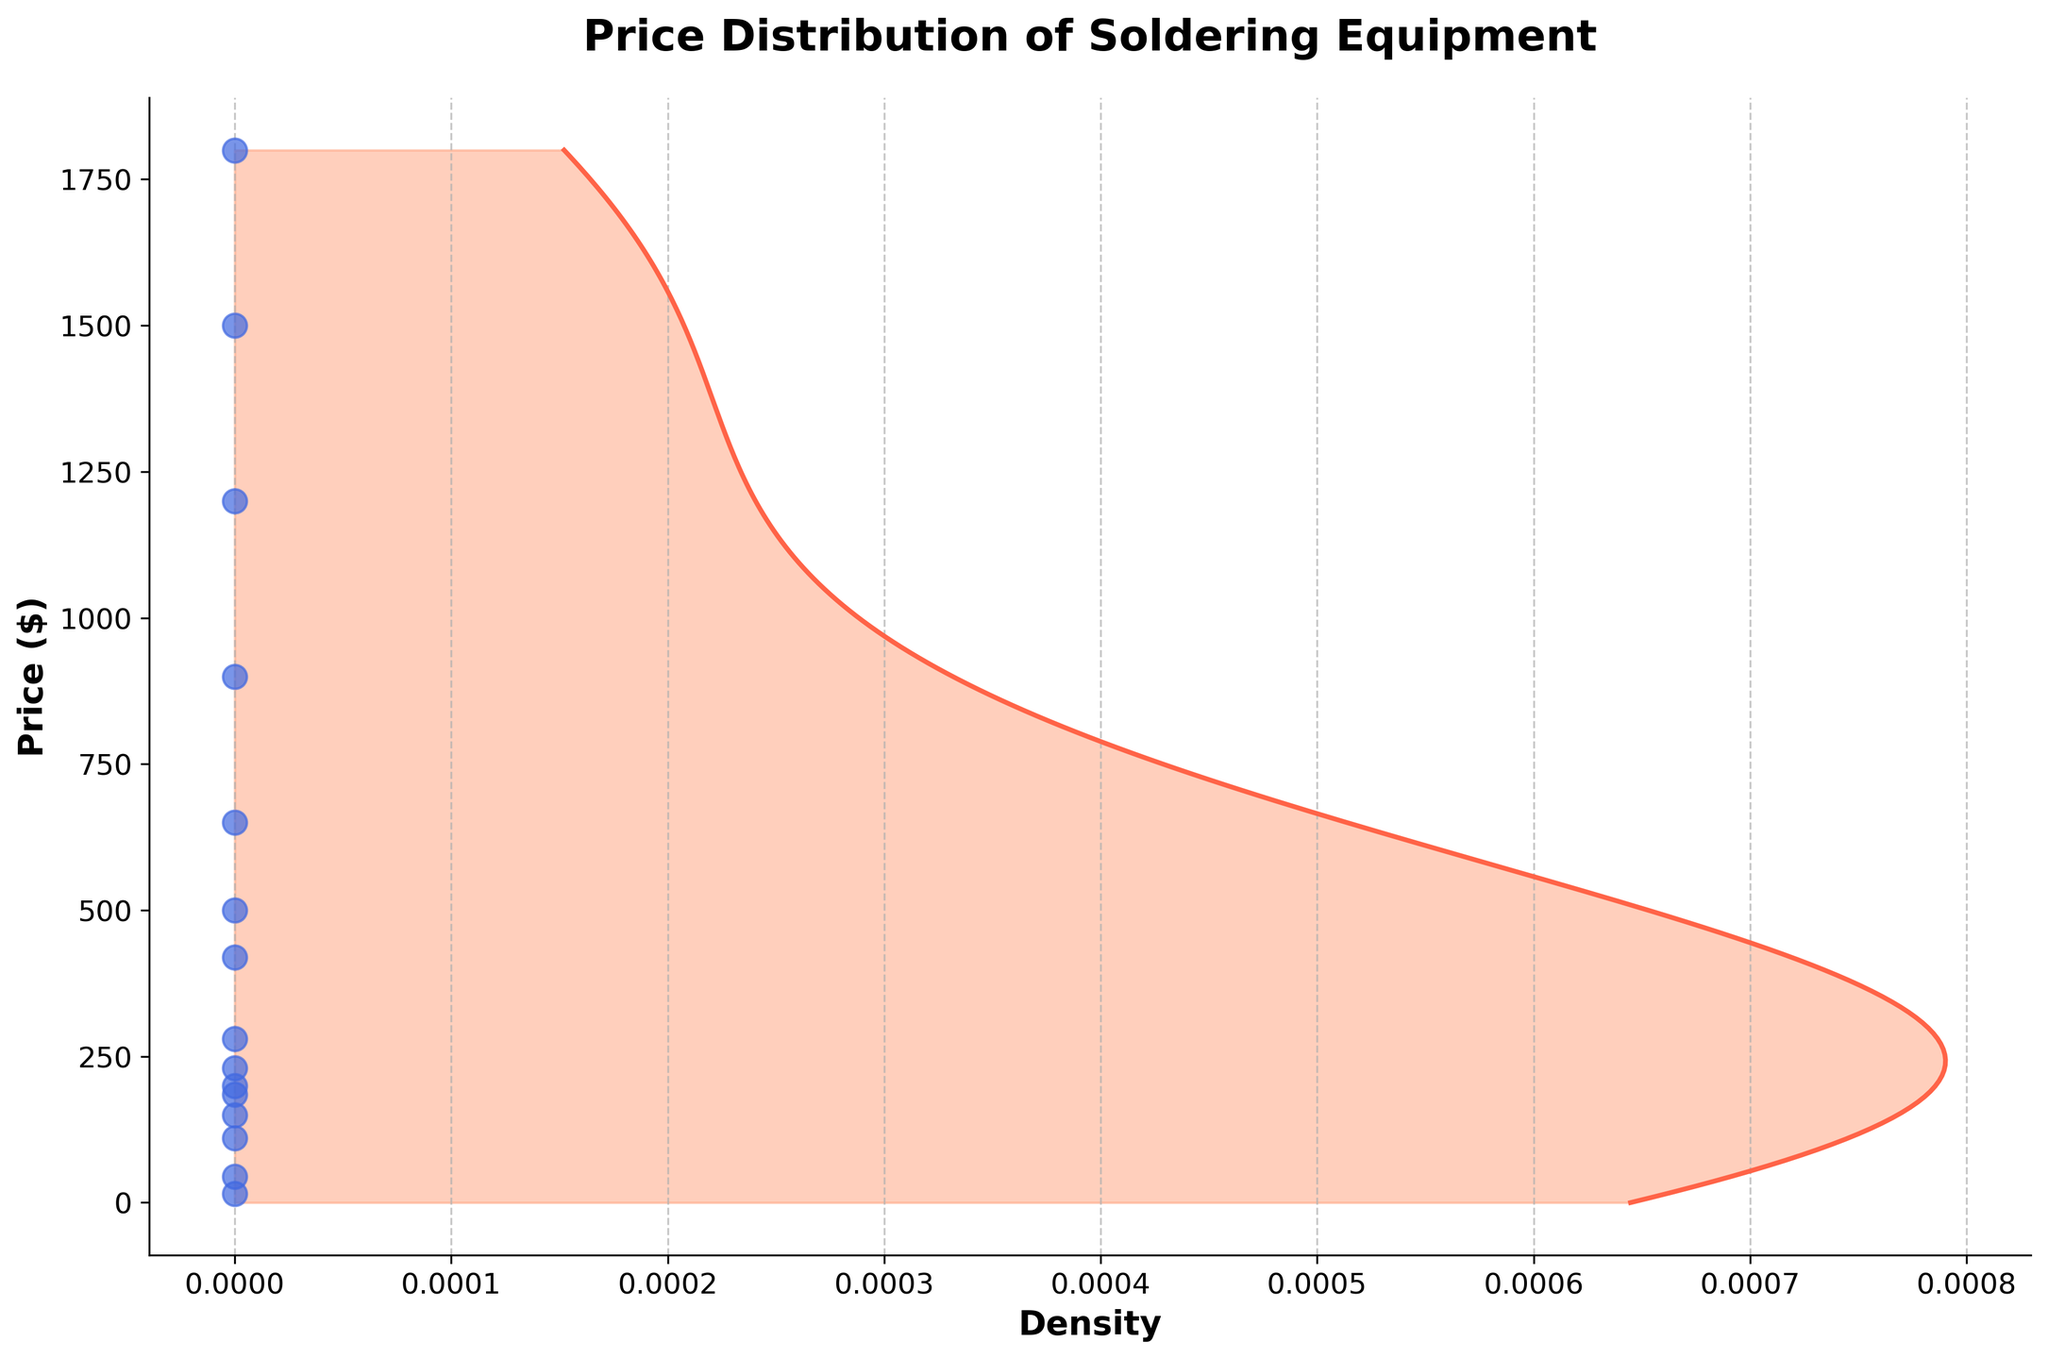What is the title of the plot? The title of the plot is usually positioned at the top of the figure and serves to provide a quick summary of what the plot is displaying. In this case, the title is located at the top center.
Answer: Price Distribution of Soldering Equipment What are the x-axis and y-axis labels used in the plot? The x-axis and y-axis labels are used to describe what each axis represents. The x-axis label is "Density" and the y-axis label is "Price ($)". This can be observed by looking at the text next to each respective axis.
Answer: Density, Price ($) How many unique soldering equipment prices are plotted as data points on the figure? The number of unique prices can be determined by counting the distinct scatter points along the y-axis. Here, each price is represented as a blue dot along the y-axis.
Answer: 15 Which soldering equipment has the highest price according to the density plot? The highest price is determined by the maximum value on the y-axis. The scatter point at this highest value represents the soldering equipment with the highest price. This can be observed as the topmost blue dot.
Answer: JBC NASE-2B advanced rework station What's the approximate price range with the highest density? The price range with the highest density can be identified by the peak of the density plot. The filled color and the solid line's peak on the x-axis indicate this range.
Answer: Approx. $100 to $300 What is the total price if you sum up the prices of the three most expensive equipment? To find this, identify the three highest scatter points on the y-axis and sum up their corresponding prices. These are 1800, 1500, and 1200.
Answer: $4500 How does the price of PACE ADS200 AccuDrive soldering station compare to the average price of all equipment? First, calculate the average price by summing all the prices and then dividing by the number of data points (15). Next, find the price of the PACE ADS200 (650) and compare it to the average. Suppose the mean price is approximately $510. Then compare 650 to 510.
Answer: Higher What's the average price of all soldering equipment in the dataset? Calculate the average by summing all the individual prices and dividing by the number of data points (15). (15+45+110+185+420+1200+150+230+280+650+200+500+1800+900+1500) / 15 gives the average.
Answer: $510 Which equipment falls within the price range with the peak density, and what is that range? Identify the peak density range on the density plot, which spans approximately from $100 to $300. Then, find the equipment prices within this range by checking the scatter points.
Answer: Weller WLC100 (45), Hakko FX-888D (110), Aoyue 968A+ (185), X-Tronic 4040-PRO (150), Weller WE1010NA (200), Quick 861DW (230), Xytronic LF-1600 (280) 